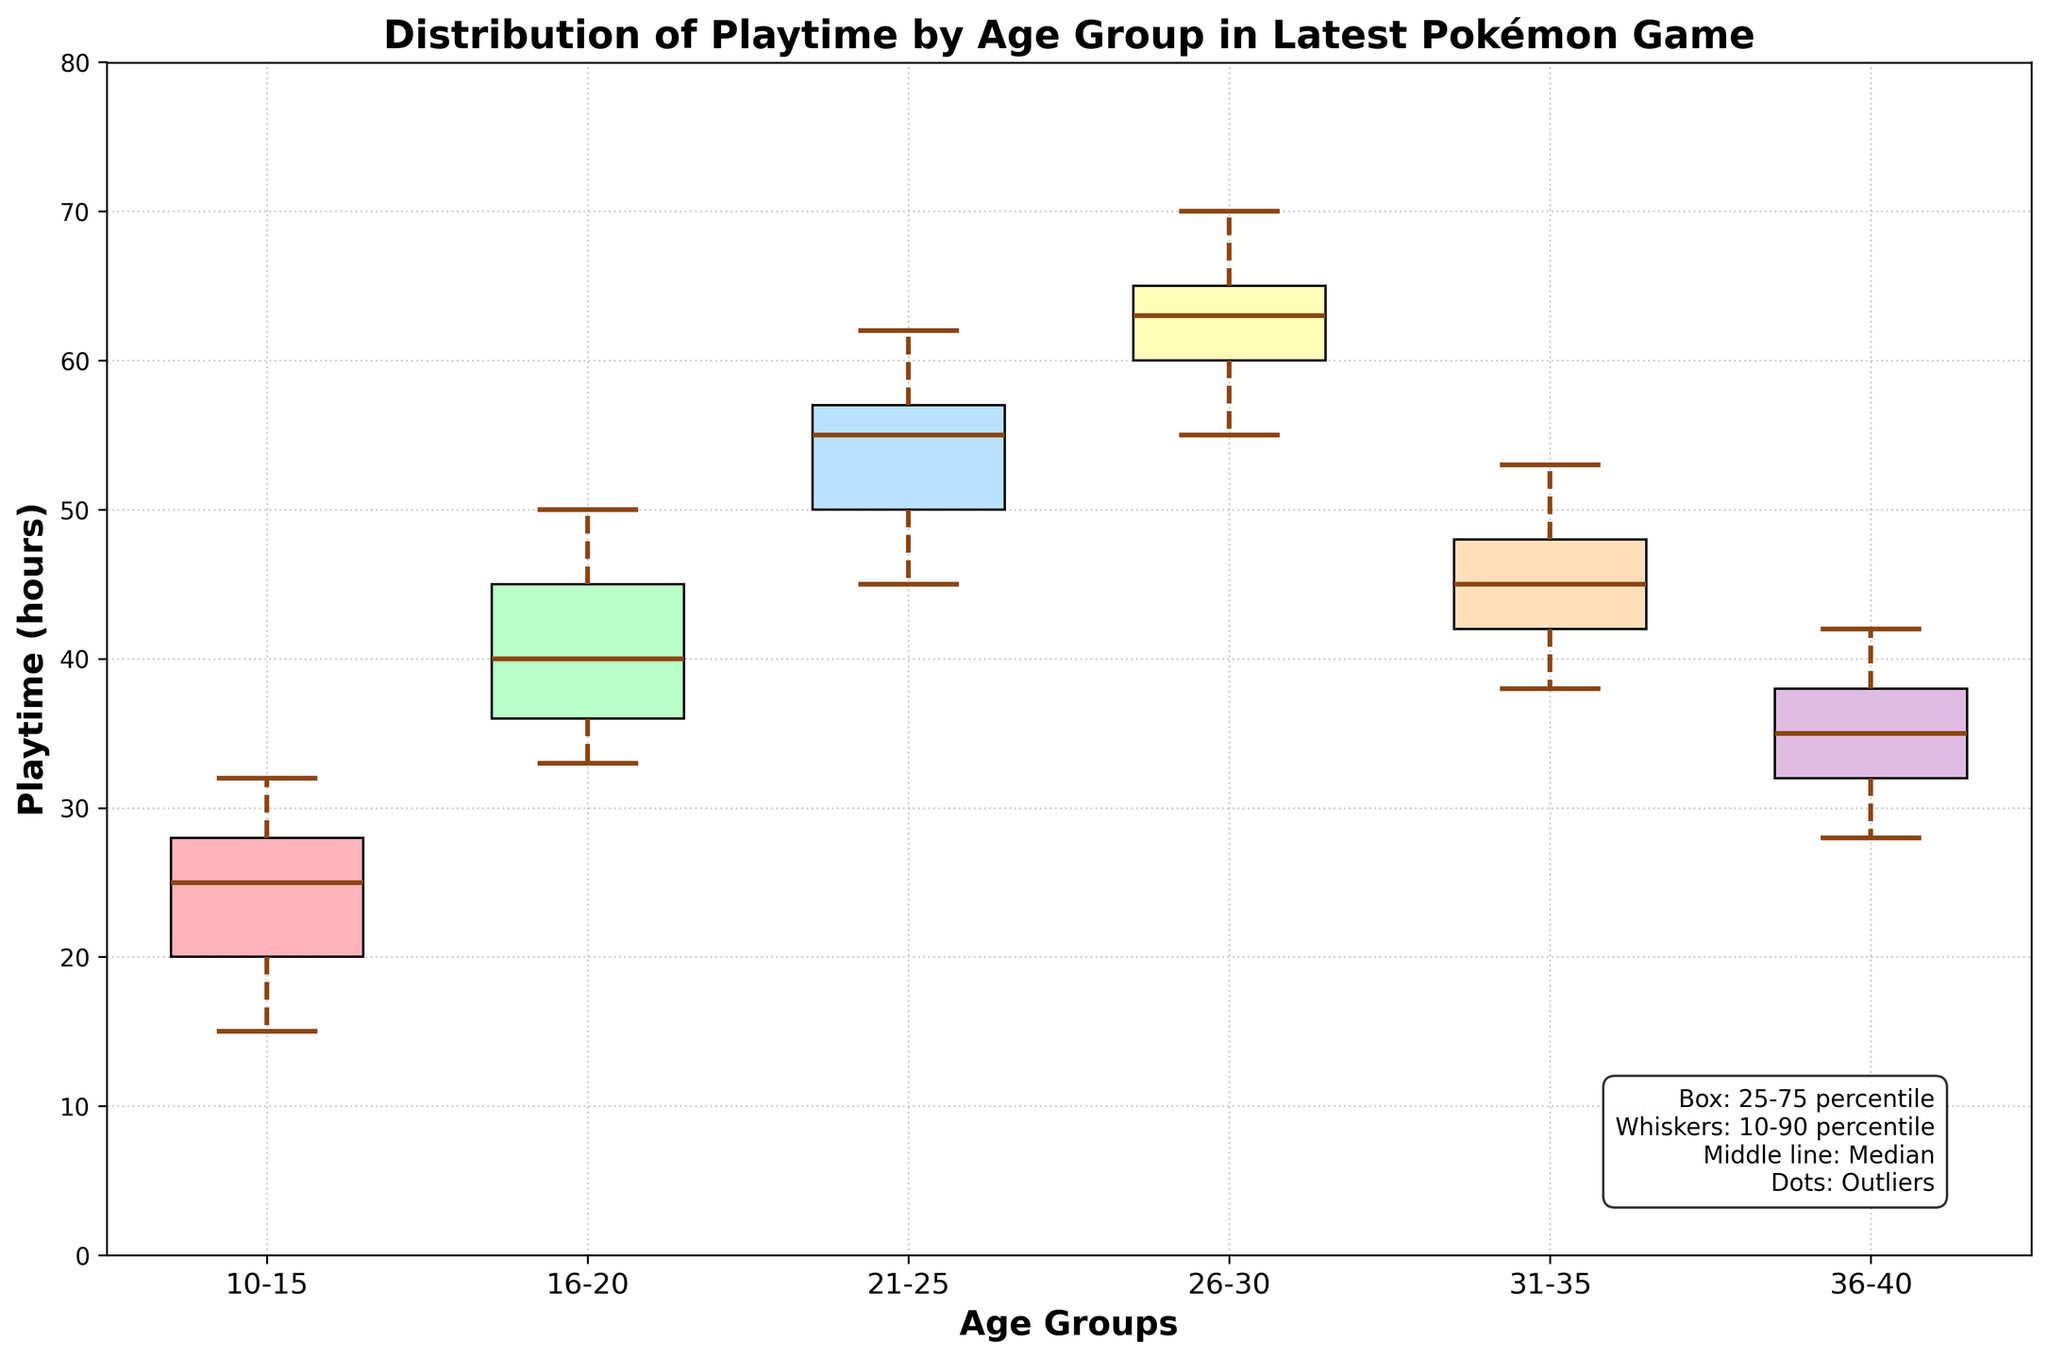What is the title of the figure? The title is usually displayed at the top of the figure in a larger font size. By looking there, we can read it directly.
Answer: Distribution of Playtime by Age Group in Latest Pokémon Game What are the labels of the x-axis and y-axis? Axis labels are typically found beside the respective axes. The x-axis label is beneath the horizontal axis, and the y-axis label is beside the vertical axis.
Answer: Age Groups, Playtime (hours) What is the age group with the highest median playtime? In a box plot, the median is represented by the line inside the box. The age group with the highest median will have this median line at the highest position on the y-axis.
Answer: 26-30 Which age group has the widest interquartile range (IQR)? The IQR is the range between the bottom and top edges of the box in a box plot. The age group with the largest distance between these two edges has the widest IQR.
Answer: 26-30 What is the color of the box plot for the age group 10-15? Each box plot has a specific color. By identifying the box corresponding to the 10-15 age group, we can determine its color.
Answer: Light red Which age group has the lowest maximum playtime observed? The maximum playtime is represented by the top whisker of the box plot. The age group with the lowest position of the top whisker on the y-axis has the lowest maximum playtime.
Answer: 36-40 What is the median playtime for the age group 21-25? The median playtime is identified by the line inside the box for the specific age group. We locate the box for the 21-25 age group and read the value at the median line.
Answer: 55 Between which age groups is the difference in median playtime the largest? To find the largest difference, compare the vertical positions of the median lines inside the box plots for each age group. The age groups with the most spaced-apart median lines will have the largest difference.
Answer: 16-20 and 26-30 How does the range of playtimes for the age group 31-35 compare to that of 21-25? The range is from the bottom to the top whisker of a box plot. By comparing the vertical spread between these points for both age groups, we can determine their ranges.
Answer: The range for 31-35 is smaller than that of 21-25 What are the details mentioned in the legend for interpreting the box plot? The legend typically provides explanations for elements of the box plot such as the box, whiskers, median, and outliers. By reading the text in the legend, we can list these details.
Answer: Box: 25-75 percentile, Whiskers: 10-90 percentile, Middle line: Median, Dots: Outliers 